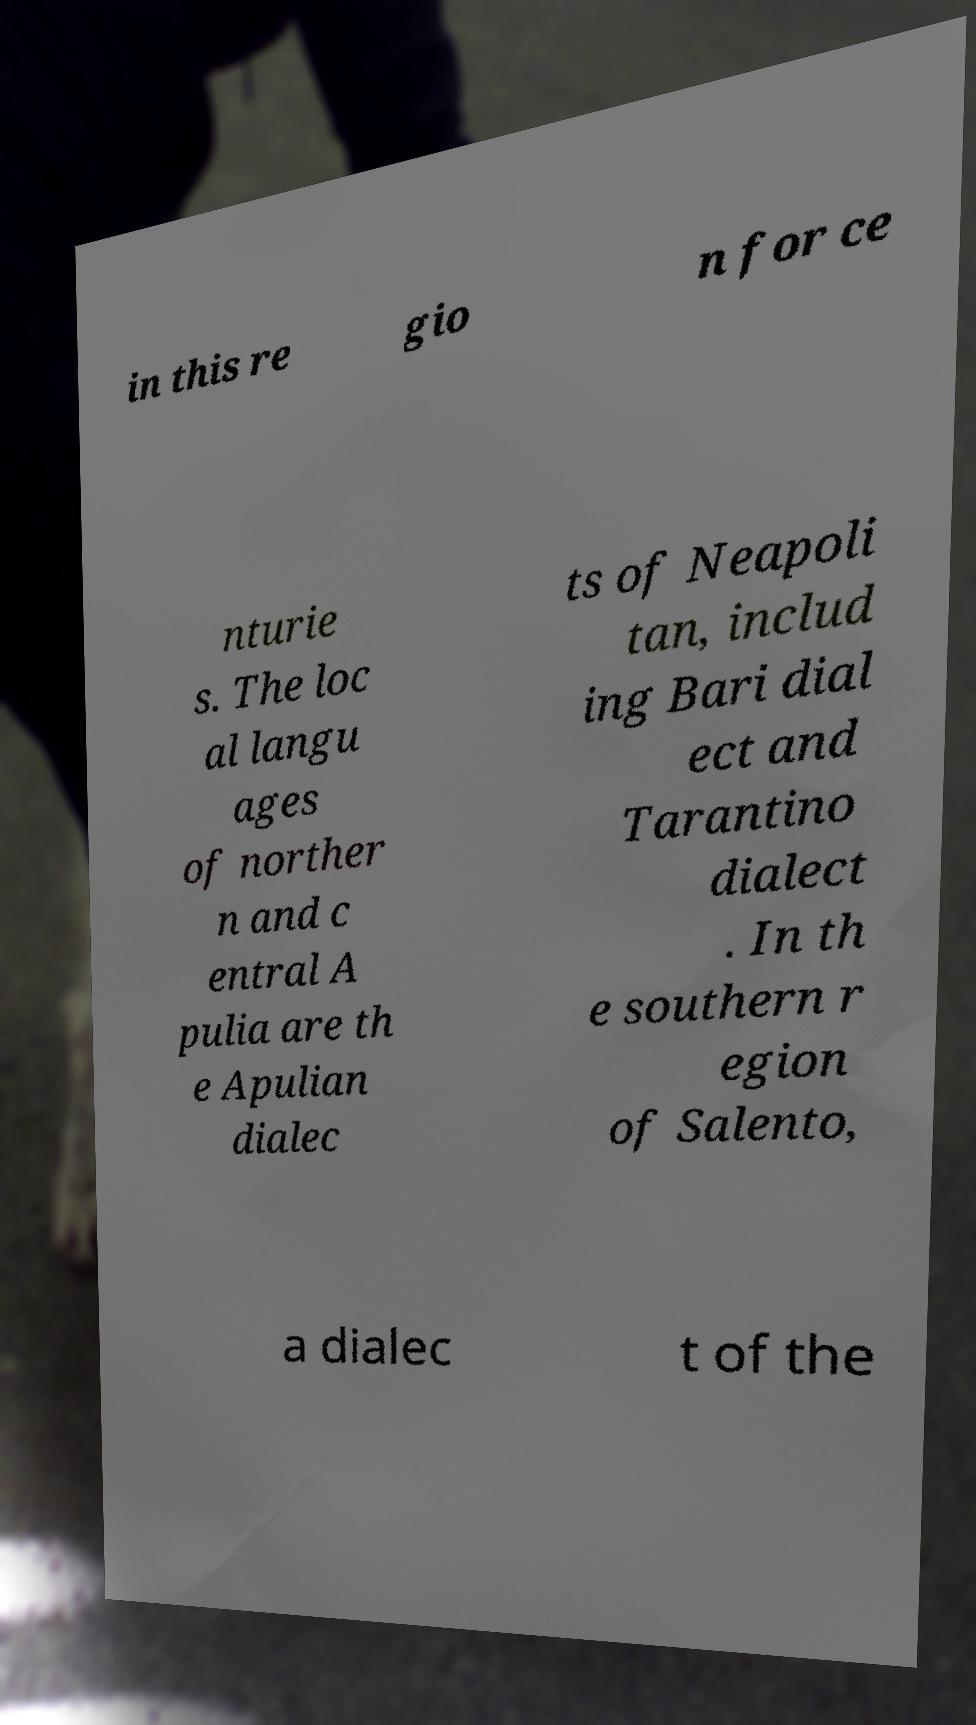Please read and relay the text visible in this image. What does it say? in this re gio n for ce nturie s. The loc al langu ages of norther n and c entral A pulia are th e Apulian dialec ts of Neapoli tan, includ ing Bari dial ect and Tarantino dialect . In th e southern r egion of Salento, a dialec t of the 